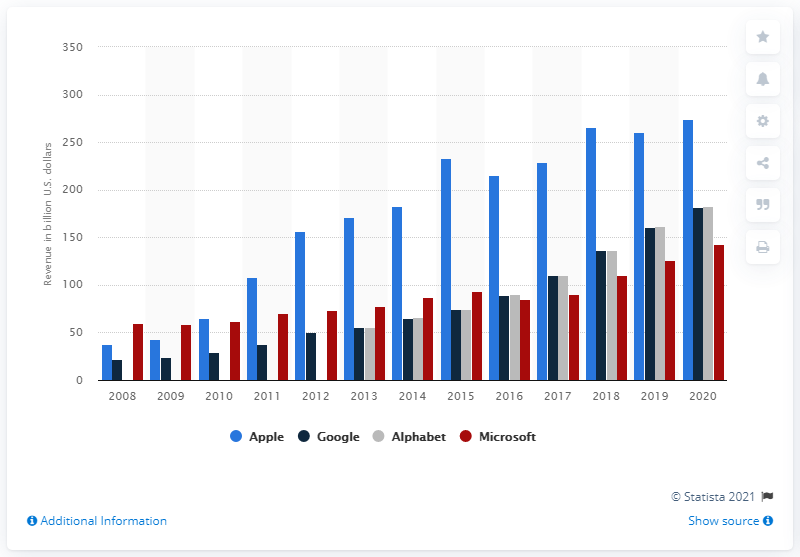List a handful of essential elements in this visual. In the fiscal year 2020, Apple generated a revenue of 274.52 billion dollars. Apple's primary competitor in the mobile phone market is Google. 